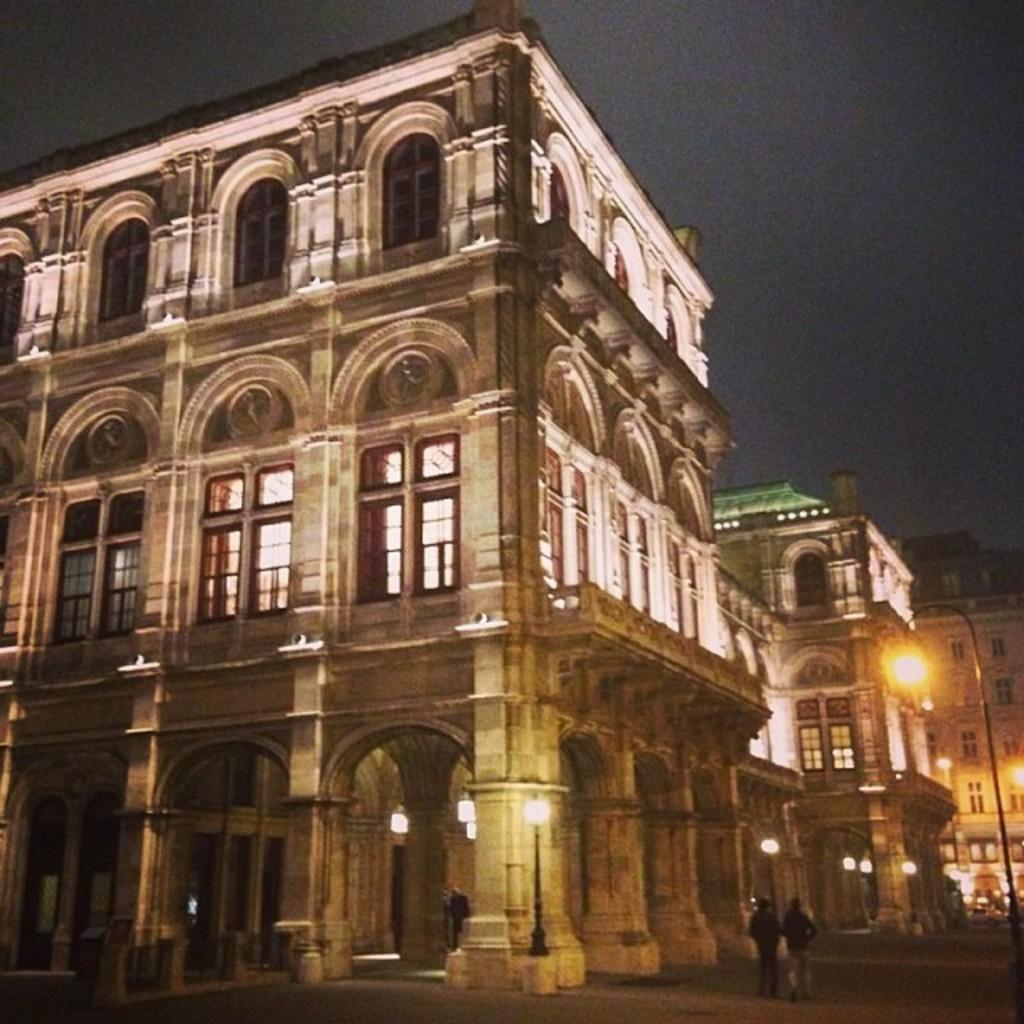What type of structures are depicted in the image? There are buildings with pillars and windows in the image. What other object can be seen in the image? There is a street light pole in the image. What can be seen in the background of the image? The sky is visible in the background of the image. What are the two persons in the image doing? Two persons are walking in the image. What features are present on the buildings? There are lights on the buildings. What type of salt is being used to season the pies in the image? There are no pies or salt present in the image. How does the breath of the persons in the image affect the surrounding environment? There is no information about the breath of the persons in the image, and therefore we cannot determine its effect on the environment. 